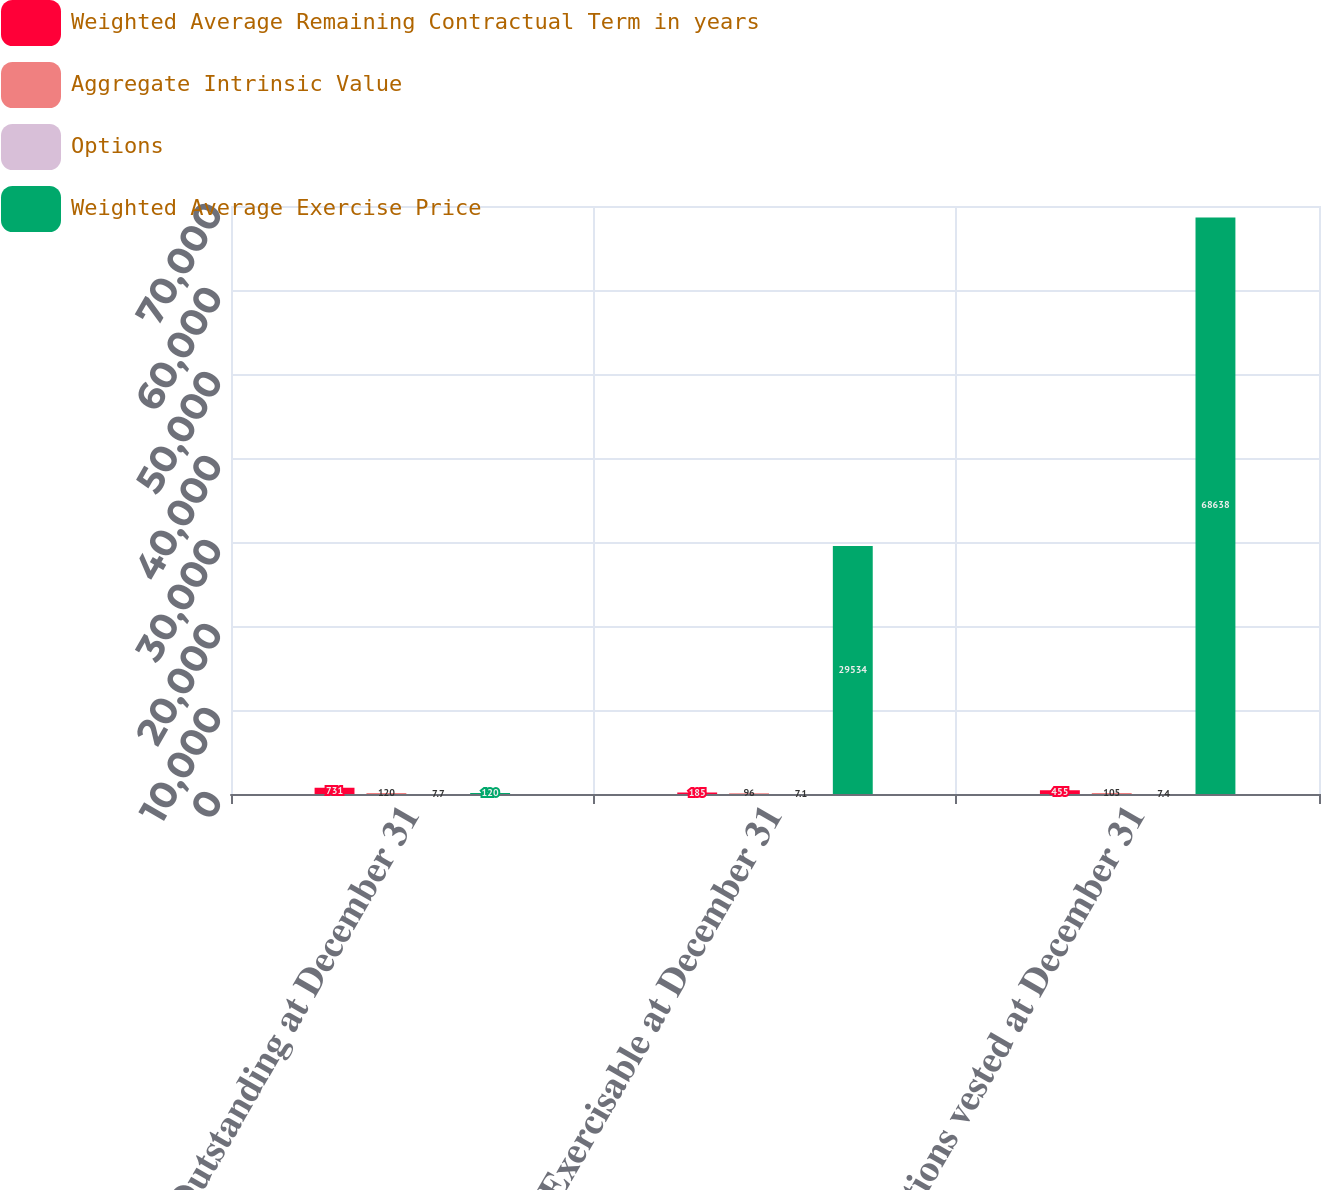Convert chart. <chart><loc_0><loc_0><loc_500><loc_500><stacked_bar_chart><ecel><fcel>Outstanding at December 31<fcel>Exercisable at December 31<fcel>Options vested at December 31<nl><fcel>Weighted Average Remaining Contractual Term in years<fcel>731<fcel>185<fcel>455<nl><fcel>Aggregate Intrinsic Value<fcel>120<fcel>96<fcel>105<nl><fcel>Options<fcel>7.7<fcel>7.1<fcel>7.4<nl><fcel>Weighted Average Exercise Price<fcel>120<fcel>29534<fcel>68638<nl></chart> 